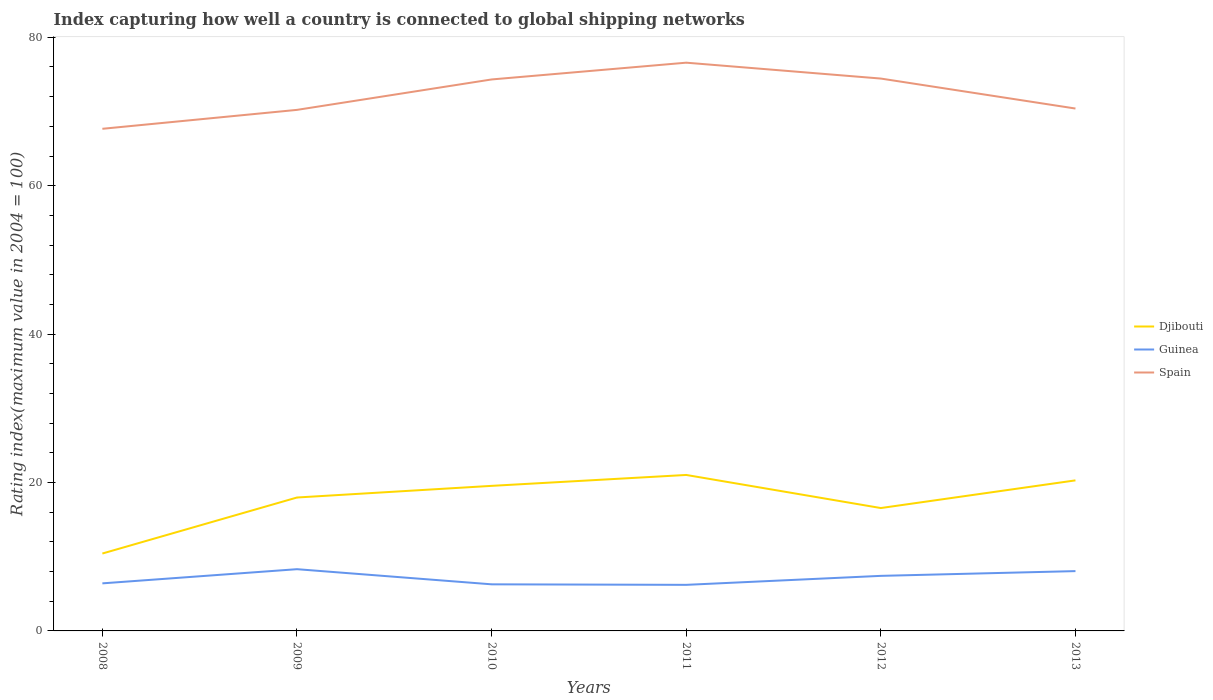Is the number of lines equal to the number of legend labels?
Your answer should be very brief. Yes. Across all years, what is the maximum rating index in Guinea?
Provide a short and direct response. 6.21. In which year was the rating index in Guinea maximum?
Give a very brief answer. 2011. What is the total rating index in Djibouti in the graph?
Offer a terse response. -7.55. What is the difference between the highest and the second highest rating index in Guinea?
Provide a short and direct response. 2.11. How many years are there in the graph?
Offer a terse response. 6. Are the values on the major ticks of Y-axis written in scientific E-notation?
Make the answer very short. No. Does the graph contain any zero values?
Provide a short and direct response. No. Does the graph contain grids?
Make the answer very short. No. Where does the legend appear in the graph?
Provide a short and direct response. Center right. How are the legend labels stacked?
Provide a succinct answer. Vertical. What is the title of the graph?
Provide a short and direct response. Index capturing how well a country is connected to global shipping networks. What is the label or title of the X-axis?
Offer a terse response. Years. What is the label or title of the Y-axis?
Offer a terse response. Rating index(maximum value in 2004 = 100). What is the Rating index(maximum value in 2004 = 100) in Djibouti in 2008?
Give a very brief answer. 10.43. What is the Rating index(maximum value in 2004 = 100) in Guinea in 2008?
Ensure brevity in your answer.  6.41. What is the Rating index(maximum value in 2004 = 100) of Spain in 2008?
Offer a very short reply. 67.67. What is the Rating index(maximum value in 2004 = 100) of Djibouti in 2009?
Offer a terse response. 17.98. What is the Rating index(maximum value in 2004 = 100) of Guinea in 2009?
Your answer should be very brief. 8.32. What is the Rating index(maximum value in 2004 = 100) of Spain in 2009?
Offer a terse response. 70.22. What is the Rating index(maximum value in 2004 = 100) of Djibouti in 2010?
Offer a terse response. 19.55. What is the Rating index(maximum value in 2004 = 100) in Guinea in 2010?
Make the answer very short. 6.28. What is the Rating index(maximum value in 2004 = 100) of Spain in 2010?
Offer a very short reply. 74.32. What is the Rating index(maximum value in 2004 = 100) in Djibouti in 2011?
Offer a terse response. 21.02. What is the Rating index(maximum value in 2004 = 100) of Guinea in 2011?
Your answer should be compact. 6.21. What is the Rating index(maximum value in 2004 = 100) of Spain in 2011?
Offer a very short reply. 76.58. What is the Rating index(maximum value in 2004 = 100) in Djibouti in 2012?
Provide a succinct answer. 16.56. What is the Rating index(maximum value in 2004 = 100) of Guinea in 2012?
Offer a very short reply. 7.42. What is the Rating index(maximum value in 2004 = 100) of Spain in 2012?
Provide a short and direct response. 74.44. What is the Rating index(maximum value in 2004 = 100) in Djibouti in 2013?
Offer a very short reply. 20.29. What is the Rating index(maximum value in 2004 = 100) in Guinea in 2013?
Provide a succinct answer. 8.06. What is the Rating index(maximum value in 2004 = 100) of Spain in 2013?
Give a very brief answer. 70.4. Across all years, what is the maximum Rating index(maximum value in 2004 = 100) of Djibouti?
Give a very brief answer. 21.02. Across all years, what is the maximum Rating index(maximum value in 2004 = 100) of Guinea?
Keep it short and to the point. 8.32. Across all years, what is the maximum Rating index(maximum value in 2004 = 100) in Spain?
Offer a very short reply. 76.58. Across all years, what is the minimum Rating index(maximum value in 2004 = 100) of Djibouti?
Make the answer very short. 10.43. Across all years, what is the minimum Rating index(maximum value in 2004 = 100) in Guinea?
Offer a terse response. 6.21. Across all years, what is the minimum Rating index(maximum value in 2004 = 100) of Spain?
Your answer should be very brief. 67.67. What is the total Rating index(maximum value in 2004 = 100) of Djibouti in the graph?
Provide a short and direct response. 105.83. What is the total Rating index(maximum value in 2004 = 100) in Guinea in the graph?
Offer a terse response. 42.7. What is the total Rating index(maximum value in 2004 = 100) in Spain in the graph?
Give a very brief answer. 433.63. What is the difference between the Rating index(maximum value in 2004 = 100) in Djibouti in 2008 and that in 2009?
Keep it short and to the point. -7.55. What is the difference between the Rating index(maximum value in 2004 = 100) of Guinea in 2008 and that in 2009?
Provide a succinct answer. -1.91. What is the difference between the Rating index(maximum value in 2004 = 100) in Spain in 2008 and that in 2009?
Provide a succinct answer. -2.55. What is the difference between the Rating index(maximum value in 2004 = 100) in Djibouti in 2008 and that in 2010?
Offer a very short reply. -9.12. What is the difference between the Rating index(maximum value in 2004 = 100) in Guinea in 2008 and that in 2010?
Offer a terse response. 0.13. What is the difference between the Rating index(maximum value in 2004 = 100) of Spain in 2008 and that in 2010?
Your answer should be very brief. -6.65. What is the difference between the Rating index(maximum value in 2004 = 100) in Djibouti in 2008 and that in 2011?
Your answer should be very brief. -10.59. What is the difference between the Rating index(maximum value in 2004 = 100) of Spain in 2008 and that in 2011?
Offer a very short reply. -8.91. What is the difference between the Rating index(maximum value in 2004 = 100) of Djibouti in 2008 and that in 2012?
Provide a short and direct response. -6.13. What is the difference between the Rating index(maximum value in 2004 = 100) of Guinea in 2008 and that in 2012?
Provide a succinct answer. -1.01. What is the difference between the Rating index(maximum value in 2004 = 100) of Spain in 2008 and that in 2012?
Offer a very short reply. -6.77. What is the difference between the Rating index(maximum value in 2004 = 100) in Djibouti in 2008 and that in 2013?
Keep it short and to the point. -9.86. What is the difference between the Rating index(maximum value in 2004 = 100) of Guinea in 2008 and that in 2013?
Your answer should be compact. -1.65. What is the difference between the Rating index(maximum value in 2004 = 100) in Spain in 2008 and that in 2013?
Make the answer very short. -2.73. What is the difference between the Rating index(maximum value in 2004 = 100) in Djibouti in 2009 and that in 2010?
Ensure brevity in your answer.  -1.57. What is the difference between the Rating index(maximum value in 2004 = 100) in Guinea in 2009 and that in 2010?
Provide a short and direct response. 2.04. What is the difference between the Rating index(maximum value in 2004 = 100) of Spain in 2009 and that in 2010?
Ensure brevity in your answer.  -4.1. What is the difference between the Rating index(maximum value in 2004 = 100) in Djibouti in 2009 and that in 2011?
Ensure brevity in your answer.  -3.04. What is the difference between the Rating index(maximum value in 2004 = 100) of Guinea in 2009 and that in 2011?
Your answer should be compact. 2.11. What is the difference between the Rating index(maximum value in 2004 = 100) of Spain in 2009 and that in 2011?
Your response must be concise. -6.36. What is the difference between the Rating index(maximum value in 2004 = 100) in Djibouti in 2009 and that in 2012?
Ensure brevity in your answer.  1.42. What is the difference between the Rating index(maximum value in 2004 = 100) in Spain in 2009 and that in 2012?
Your response must be concise. -4.22. What is the difference between the Rating index(maximum value in 2004 = 100) of Djibouti in 2009 and that in 2013?
Keep it short and to the point. -2.31. What is the difference between the Rating index(maximum value in 2004 = 100) of Guinea in 2009 and that in 2013?
Your answer should be very brief. 0.26. What is the difference between the Rating index(maximum value in 2004 = 100) in Spain in 2009 and that in 2013?
Provide a short and direct response. -0.18. What is the difference between the Rating index(maximum value in 2004 = 100) in Djibouti in 2010 and that in 2011?
Make the answer very short. -1.47. What is the difference between the Rating index(maximum value in 2004 = 100) of Guinea in 2010 and that in 2011?
Ensure brevity in your answer.  0.07. What is the difference between the Rating index(maximum value in 2004 = 100) in Spain in 2010 and that in 2011?
Ensure brevity in your answer.  -2.26. What is the difference between the Rating index(maximum value in 2004 = 100) in Djibouti in 2010 and that in 2012?
Offer a terse response. 2.99. What is the difference between the Rating index(maximum value in 2004 = 100) of Guinea in 2010 and that in 2012?
Offer a very short reply. -1.14. What is the difference between the Rating index(maximum value in 2004 = 100) of Spain in 2010 and that in 2012?
Provide a succinct answer. -0.12. What is the difference between the Rating index(maximum value in 2004 = 100) of Djibouti in 2010 and that in 2013?
Ensure brevity in your answer.  -0.74. What is the difference between the Rating index(maximum value in 2004 = 100) in Guinea in 2010 and that in 2013?
Your response must be concise. -1.78. What is the difference between the Rating index(maximum value in 2004 = 100) of Spain in 2010 and that in 2013?
Your answer should be compact. 3.92. What is the difference between the Rating index(maximum value in 2004 = 100) in Djibouti in 2011 and that in 2012?
Keep it short and to the point. 4.46. What is the difference between the Rating index(maximum value in 2004 = 100) in Guinea in 2011 and that in 2012?
Keep it short and to the point. -1.21. What is the difference between the Rating index(maximum value in 2004 = 100) in Spain in 2011 and that in 2012?
Make the answer very short. 2.14. What is the difference between the Rating index(maximum value in 2004 = 100) in Djibouti in 2011 and that in 2013?
Provide a succinct answer. 0.73. What is the difference between the Rating index(maximum value in 2004 = 100) in Guinea in 2011 and that in 2013?
Provide a short and direct response. -1.85. What is the difference between the Rating index(maximum value in 2004 = 100) in Spain in 2011 and that in 2013?
Your answer should be very brief. 6.18. What is the difference between the Rating index(maximum value in 2004 = 100) in Djibouti in 2012 and that in 2013?
Provide a short and direct response. -3.73. What is the difference between the Rating index(maximum value in 2004 = 100) in Guinea in 2012 and that in 2013?
Your answer should be compact. -0.64. What is the difference between the Rating index(maximum value in 2004 = 100) of Spain in 2012 and that in 2013?
Provide a succinct answer. 4.04. What is the difference between the Rating index(maximum value in 2004 = 100) of Djibouti in 2008 and the Rating index(maximum value in 2004 = 100) of Guinea in 2009?
Offer a very short reply. 2.11. What is the difference between the Rating index(maximum value in 2004 = 100) of Djibouti in 2008 and the Rating index(maximum value in 2004 = 100) of Spain in 2009?
Make the answer very short. -59.79. What is the difference between the Rating index(maximum value in 2004 = 100) in Guinea in 2008 and the Rating index(maximum value in 2004 = 100) in Spain in 2009?
Provide a short and direct response. -63.81. What is the difference between the Rating index(maximum value in 2004 = 100) of Djibouti in 2008 and the Rating index(maximum value in 2004 = 100) of Guinea in 2010?
Your answer should be very brief. 4.15. What is the difference between the Rating index(maximum value in 2004 = 100) in Djibouti in 2008 and the Rating index(maximum value in 2004 = 100) in Spain in 2010?
Offer a very short reply. -63.89. What is the difference between the Rating index(maximum value in 2004 = 100) of Guinea in 2008 and the Rating index(maximum value in 2004 = 100) of Spain in 2010?
Your answer should be very brief. -67.91. What is the difference between the Rating index(maximum value in 2004 = 100) of Djibouti in 2008 and the Rating index(maximum value in 2004 = 100) of Guinea in 2011?
Provide a short and direct response. 4.22. What is the difference between the Rating index(maximum value in 2004 = 100) in Djibouti in 2008 and the Rating index(maximum value in 2004 = 100) in Spain in 2011?
Provide a short and direct response. -66.15. What is the difference between the Rating index(maximum value in 2004 = 100) in Guinea in 2008 and the Rating index(maximum value in 2004 = 100) in Spain in 2011?
Provide a succinct answer. -70.17. What is the difference between the Rating index(maximum value in 2004 = 100) in Djibouti in 2008 and the Rating index(maximum value in 2004 = 100) in Guinea in 2012?
Offer a very short reply. 3.01. What is the difference between the Rating index(maximum value in 2004 = 100) of Djibouti in 2008 and the Rating index(maximum value in 2004 = 100) of Spain in 2012?
Offer a terse response. -64.01. What is the difference between the Rating index(maximum value in 2004 = 100) of Guinea in 2008 and the Rating index(maximum value in 2004 = 100) of Spain in 2012?
Your answer should be compact. -68.03. What is the difference between the Rating index(maximum value in 2004 = 100) of Djibouti in 2008 and the Rating index(maximum value in 2004 = 100) of Guinea in 2013?
Keep it short and to the point. 2.37. What is the difference between the Rating index(maximum value in 2004 = 100) of Djibouti in 2008 and the Rating index(maximum value in 2004 = 100) of Spain in 2013?
Keep it short and to the point. -59.97. What is the difference between the Rating index(maximum value in 2004 = 100) of Guinea in 2008 and the Rating index(maximum value in 2004 = 100) of Spain in 2013?
Ensure brevity in your answer.  -63.99. What is the difference between the Rating index(maximum value in 2004 = 100) of Djibouti in 2009 and the Rating index(maximum value in 2004 = 100) of Guinea in 2010?
Offer a terse response. 11.7. What is the difference between the Rating index(maximum value in 2004 = 100) of Djibouti in 2009 and the Rating index(maximum value in 2004 = 100) of Spain in 2010?
Offer a terse response. -56.34. What is the difference between the Rating index(maximum value in 2004 = 100) in Guinea in 2009 and the Rating index(maximum value in 2004 = 100) in Spain in 2010?
Provide a succinct answer. -66. What is the difference between the Rating index(maximum value in 2004 = 100) in Djibouti in 2009 and the Rating index(maximum value in 2004 = 100) in Guinea in 2011?
Offer a terse response. 11.77. What is the difference between the Rating index(maximum value in 2004 = 100) in Djibouti in 2009 and the Rating index(maximum value in 2004 = 100) in Spain in 2011?
Make the answer very short. -58.6. What is the difference between the Rating index(maximum value in 2004 = 100) in Guinea in 2009 and the Rating index(maximum value in 2004 = 100) in Spain in 2011?
Your answer should be compact. -68.26. What is the difference between the Rating index(maximum value in 2004 = 100) in Djibouti in 2009 and the Rating index(maximum value in 2004 = 100) in Guinea in 2012?
Your response must be concise. 10.56. What is the difference between the Rating index(maximum value in 2004 = 100) of Djibouti in 2009 and the Rating index(maximum value in 2004 = 100) of Spain in 2012?
Offer a terse response. -56.46. What is the difference between the Rating index(maximum value in 2004 = 100) of Guinea in 2009 and the Rating index(maximum value in 2004 = 100) of Spain in 2012?
Make the answer very short. -66.12. What is the difference between the Rating index(maximum value in 2004 = 100) in Djibouti in 2009 and the Rating index(maximum value in 2004 = 100) in Guinea in 2013?
Keep it short and to the point. 9.92. What is the difference between the Rating index(maximum value in 2004 = 100) in Djibouti in 2009 and the Rating index(maximum value in 2004 = 100) in Spain in 2013?
Your answer should be compact. -52.42. What is the difference between the Rating index(maximum value in 2004 = 100) of Guinea in 2009 and the Rating index(maximum value in 2004 = 100) of Spain in 2013?
Your answer should be very brief. -62.08. What is the difference between the Rating index(maximum value in 2004 = 100) in Djibouti in 2010 and the Rating index(maximum value in 2004 = 100) in Guinea in 2011?
Make the answer very short. 13.34. What is the difference between the Rating index(maximum value in 2004 = 100) of Djibouti in 2010 and the Rating index(maximum value in 2004 = 100) of Spain in 2011?
Provide a short and direct response. -57.03. What is the difference between the Rating index(maximum value in 2004 = 100) of Guinea in 2010 and the Rating index(maximum value in 2004 = 100) of Spain in 2011?
Ensure brevity in your answer.  -70.3. What is the difference between the Rating index(maximum value in 2004 = 100) of Djibouti in 2010 and the Rating index(maximum value in 2004 = 100) of Guinea in 2012?
Make the answer very short. 12.13. What is the difference between the Rating index(maximum value in 2004 = 100) of Djibouti in 2010 and the Rating index(maximum value in 2004 = 100) of Spain in 2012?
Provide a short and direct response. -54.89. What is the difference between the Rating index(maximum value in 2004 = 100) of Guinea in 2010 and the Rating index(maximum value in 2004 = 100) of Spain in 2012?
Offer a very short reply. -68.16. What is the difference between the Rating index(maximum value in 2004 = 100) of Djibouti in 2010 and the Rating index(maximum value in 2004 = 100) of Guinea in 2013?
Keep it short and to the point. 11.49. What is the difference between the Rating index(maximum value in 2004 = 100) of Djibouti in 2010 and the Rating index(maximum value in 2004 = 100) of Spain in 2013?
Your answer should be compact. -50.85. What is the difference between the Rating index(maximum value in 2004 = 100) of Guinea in 2010 and the Rating index(maximum value in 2004 = 100) of Spain in 2013?
Offer a terse response. -64.12. What is the difference between the Rating index(maximum value in 2004 = 100) of Djibouti in 2011 and the Rating index(maximum value in 2004 = 100) of Guinea in 2012?
Make the answer very short. 13.6. What is the difference between the Rating index(maximum value in 2004 = 100) in Djibouti in 2011 and the Rating index(maximum value in 2004 = 100) in Spain in 2012?
Your response must be concise. -53.42. What is the difference between the Rating index(maximum value in 2004 = 100) of Guinea in 2011 and the Rating index(maximum value in 2004 = 100) of Spain in 2012?
Your answer should be compact. -68.23. What is the difference between the Rating index(maximum value in 2004 = 100) of Djibouti in 2011 and the Rating index(maximum value in 2004 = 100) of Guinea in 2013?
Provide a short and direct response. 12.96. What is the difference between the Rating index(maximum value in 2004 = 100) of Djibouti in 2011 and the Rating index(maximum value in 2004 = 100) of Spain in 2013?
Make the answer very short. -49.38. What is the difference between the Rating index(maximum value in 2004 = 100) of Guinea in 2011 and the Rating index(maximum value in 2004 = 100) of Spain in 2013?
Give a very brief answer. -64.19. What is the difference between the Rating index(maximum value in 2004 = 100) in Djibouti in 2012 and the Rating index(maximum value in 2004 = 100) in Spain in 2013?
Make the answer very short. -53.84. What is the difference between the Rating index(maximum value in 2004 = 100) of Guinea in 2012 and the Rating index(maximum value in 2004 = 100) of Spain in 2013?
Offer a very short reply. -62.98. What is the average Rating index(maximum value in 2004 = 100) in Djibouti per year?
Provide a short and direct response. 17.64. What is the average Rating index(maximum value in 2004 = 100) of Guinea per year?
Give a very brief answer. 7.12. What is the average Rating index(maximum value in 2004 = 100) of Spain per year?
Your answer should be compact. 72.27. In the year 2008, what is the difference between the Rating index(maximum value in 2004 = 100) of Djibouti and Rating index(maximum value in 2004 = 100) of Guinea?
Keep it short and to the point. 4.02. In the year 2008, what is the difference between the Rating index(maximum value in 2004 = 100) in Djibouti and Rating index(maximum value in 2004 = 100) in Spain?
Give a very brief answer. -57.24. In the year 2008, what is the difference between the Rating index(maximum value in 2004 = 100) of Guinea and Rating index(maximum value in 2004 = 100) of Spain?
Offer a very short reply. -61.26. In the year 2009, what is the difference between the Rating index(maximum value in 2004 = 100) of Djibouti and Rating index(maximum value in 2004 = 100) of Guinea?
Offer a very short reply. 9.66. In the year 2009, what is the difference between the Rating index(maximum value in 2004 = 100) in Djibouti and Rating index(maximum value in 2004 = 100) in Spain?
Your answer should be very brief. -52.24. In the year 2009, what is the difference between the Rating index(maximum value in 2004 = 100) in Guinea and Rating index(maximum value in 2004 = 100) in Spain?
Provide a short and direct response. -61.9. In the year 2010, what is the difference between the Rating index(maximum value in 2004 = 100) of Djibouti and Rating index(maximum value in 2004 = 100) of Guinea?
Give a very brief answer. 13.27. In the year 2010, what is the difference between the Rating index(maximum value in 2004 = 100) of Djibouti and Rating index(maximum value in 2004 = 100) of Spain?
Give a very brief answer. -54.77. In the year 2010, what is the difference between the Rating index(maximum value in 2004 = 100) in Guinea and Rating index(maximum value in 2004 = 100) in Spain?
Provide a short and direct response. -68.04. In the year 2011, what is the difference between the Rating index(maximum value in 2004 = 100) of Djibouti and Rating index(maximum value in 2004 = 100) of Guinea?
Make the answer very short. 14.81. In the year 2011, what is the difference between the Rating index(maximum value in 2004 = 100) in Djibouti and Rating index(maximum value in 2004 = 100) in Spain?
Give a very brief answer. -55.56. In the year 2011, what is the difference between the Rating index(maximum value in 2004 = 100) in Guinea and Rating index(maximum value in 2004 = 100) in Spain?
Your answer should be compact. -70.37. In the year 2012, what is the difference between the Rating index(maximum value in 2004 = 100) of Djibouti and Rating index(maximum value in 2004 = 100) of Guinea?
Provide a short and direct response. 9.14. In the year 2012, what is the difference between the Rating index(maximum value in 2004 = 100) of Djibouti and Rating index(maximum value in 2004 = 100) of Spain?
Offer a very short reply. -57.88. In the year 2012, what is the difference between the Rating index(maximum value in 2004 = 100) of Guinea and Rating index(maximum value in 2004 = 100) of Spain?
Provide a short and direct response. -67.02. In the year 2013, what is the difference between the Rating index(maximum value in 2004 = 100) in Djibouti and Rating index(maximum value in 2004 = 100) in Guinea?
Give a very brief answer. 12.23. In the year 2013, what is the difference between the Rating index(maximum value in 2004 = 100) of Djibouti and Rating index(maximum value in 2004 = 100) of Spain?
Ensure brevity in your answer.  -50.11. In the year 2013, what is the difference between the Rating index(maximum value in 2004 = 100) in Guinea and Rating index(maximum value in 2004 = 100) in Spain?
Offer a very short reply. -62.34. What is the ratio of the Rating index(maximum value in 2004 = 100) in Djibouti in 2008 to that in 2009?
Provide a succinct answer. 0.58. What is the ratio of the Rating index(maximum value in 2004 = 100) in Guinea in 2008 to that in 2009?
Your response must be concise. 0.77. What is the ratio of the Rating index(maximum value in 2004 = 100) of Spain in 2008 to that in 2009?
Offer a very short reply. 0.96. What is the ratio of the Rating index(maximum value in 2004 = 100) in Djibouti in 2008 to that in 2010?
Your response must be concise. 0.53. What is the ratio of the Rating index(maximum value in 2004 = 100) of Guinea in 2008 to that in 2010?
Give a very brief answer. 1.02. What is the ratio of the Rating index(maximum value in 2004 = 100) of Spain in 2008 to that in 2010?
Offer a very short reply. 0.91. What is the ratio of the Rating index(maximum value in 2004 = 100) in Djibouti in 2008 to that in 2011?
Ensure brevity in your answer.  0.5. What is the ratio of the Rating index(maximum value in 2004 = 100) of Guinea in 2008 to that in 2011?
Offer a terse response. 1.03. What is the ratio of the Rating index(maximum value in 2004 = 100) of Spain in 2008 to that in 2011?
Provide a short and direct response. 0.88. What is the ratio of the Rating index(maximum value in 2004 = 100) of Djibouti in 2008 to that in 2012?
Offer a very short reply. 0.63. What is the ratio of the Rating index(maximum value in 2004 = 100) of Guinea in 2008 to that in 2012?
Make the answer very short. 0.86. What is the ratio of the Rating index(maximum value in 2004 = 100) in Djibouti in 2008 to that in 2013?
Give a very brief answer. 0.51. What is the ratio of the Rating index(maximum value in 2004 = 100) in Guinea in 2008 to that in 2013?
Your answer should be very brief. 0.8. What is the ratio of the Rating index(maximum value in 2004 = 100) of Spain in 2008 to that in 2013?
Provide a short and direct response. 0.96. What is the ratio of the Rating index(maximum value in 2004 = 100) of Djibouti in 2009 to that in 2010?
Keep it short and to the point. 0.92. What is the ratio of the Rating index(maximum value in 2004 = 100) of Guinea in 2009 to that in 2010?
Ensure brevity in your answer.  1.32. What is the ratio of the Rating index(maximum value in 2004 = 100) in Spain in 2009 to that in 2010?
Make the answer very short. 0.94. What is the ratio of the Rating index(maximum value in 2004 = 100) in Djibouti in 2009 to that in 2011?
Keep it short and to the point. 0.86. What is the ratio of the Rating index(maximum value in 2004 = 100) of Guinea in 2009 to that in 2011?
Give a very brief answer. 1.34. What is the ratio of the Rating index(maximum value in 2004 = 100) of Spain in 2009 to that in 2011?
Your answer should be very brief. 0.92. What is the ratio of the Rating index(maximum value in 2004 = 100) in Djibouti in 2009 to that in 2012?
Provide a short and direct response. 1.09. What is the ratio of the Rating index(maximum value in 2004 = 100) of Guinea in 2009 to that in 2012?
Provide a succinct answer. 1.12. What is the ratio of the Rating index(maximum value in 2004 = 100) in Spain in 2009 to that in 2012?
Offer a terse response. 0.94. What is the ratio of the Rating index(maximum value in 2004 = 100) of Djibouti in 2009 to that in 2013?
Offer a terse response. 0.89. What is the ratio of the Rating index(maximum value in 2004 = 100) in Guinea in 2009 to that in 2013?
Give a very brief answer. 1.03. What is the ratio of the Rating index(maximum value in 2004 = 100) of Djibouti in 2010 to that in 2011?
Offer a very short reply. 0.93. What is the ratio of the Rating index(maximum value in 2004 = 100) in Guinea in 2010 to that in 2011?
Your answer should be very brief. 1.01. What is the ratio of the Rating index(maximum value in 2004 = 100) of Spain in 2010 to that in 2011?
Give a very brief answer. 0.97. What is the ratio of the Rating index(maximum value in 2004 = 100) in Djibouti in 2010 to that in 2012?
Your response must be concise. 1.18. What is the ratio of the Rating index(maximum value in 2004 = 100) of Guinea in 2010 to that in 2012?
Offer a very short reply. 0.85. What is the ratio of the Rating index(maximum value in 2004 = 100) in Djibouti in 2010 to that in 2013?
Make the answer very short. 0.96. What is the ratio of the Rating index(maximum value in 2004 = 100) of Guinea in 2010 to that in 2013?
Give a very brief answer. 0.78. What is the ratio of the Rating index(maximum value in 2004 = 100) in Spain in 2010 to that in 2013?
Give a very brief answer. 1.06. What is the ratio of the Rating index(maximum value in 2004 = 100) in Djibouti in 2011 to that in 2012?
Keep it short and to the point. 1.27. What is the ratio of the Rating index(maximum value in 2004 = 100) in Guinea in 2011 to that in 2012?
Provide a short and direct response. 0.84. What is the ratio of the Rating index(maximum value in 2004 = 100) of Spain in 2011 to that in 2012?
Make the answer very short. 1.03. What is the ratio of the Rating index(maximum value in 2004 = 100) of Djibouti in 2011 to that in 2013?
Your answer should be very brief. 1.04. What is the ratio of the Rating index(maximum value in 2004 = 100) in Guinea in 2011 to that in 2013?
Your answer should be very brief. 0.77. What is the ratio of the Rating index(maximum value in 2004 = 100) of Spain in 2011 to that in 2013?
Offer a terse response. 1.09. What is the ratio of the Rating index(maximum value in 2004 = 100) in Djibouti in 2012 to that in 2013?
Provide a succinct answer. 0.82. What is the ratio of the Rating index(maximum value in 2004 = 100) in Guinea in 2012 to that in 2013?
Your answer should be very brief. 0.92. What is the ratio of the Rating index(maximum value in 2004 = 100) in Spain in 2012 to that in 2013?
Ensure brevity in your answer.  1.06. What is the difference between the highest and the second highest Rating index(maximum value in 2004 = 100) of Djibouti?
Offer a terse response. 0.73. What is the difference between the highest and the second highest Rating index(maximum value in 2004 = 100) of Guinea?
Make the answer very short. 0.26. What is the difference between the highest and the second highest Rating index(maximum value in 2004 = 100) in Spain?
Give a very brief answer. 2.14. What is the difference between the highest and the lowest Rating index(maximum value in 2004 = 100) in Djibouti?
Provide a succinct answer. 10.59. What is the difference between the highest and the lowest Rating index(maximum value in 2004 = 100) of Guinea?
Make the answer very short. 2.11. What is the difference between the highest and the lowest Rating index(maximum value in 2004 = 100) in Spain?
Keep it short and to the point. 8.91. 